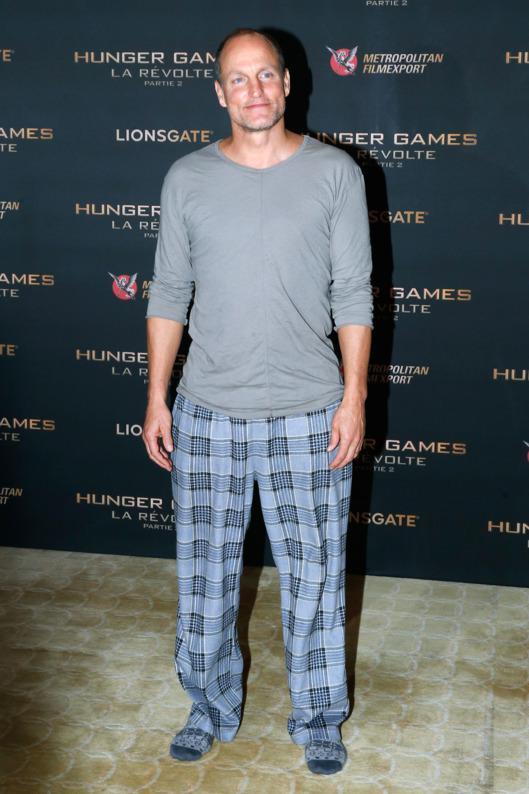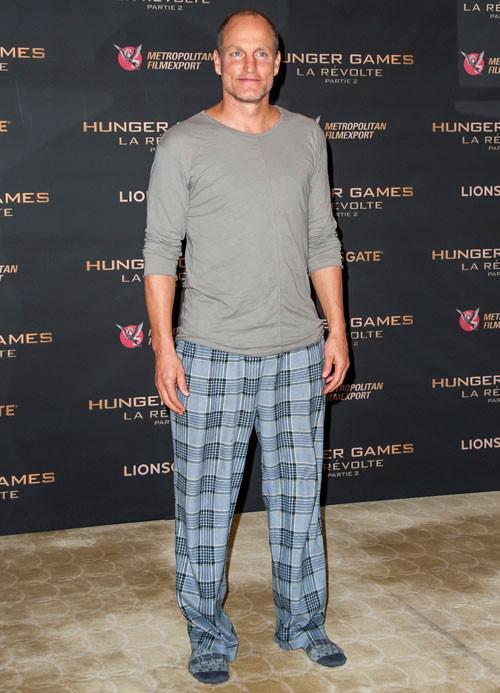The first image is the image on the left, the second image is the image on the right. Evaluate the accuracy of this statement regarding the images: "A man is wearing plaid pajama pants in the image on the right.". Is it true? Answer yes or no. Yes. The first image is the image on the left, the second image is the image on the right. For the images displayed, is the sentence "A man's silky diamond design pajama shirt has contrasting color at the collar, sleeve cuffs and pocket edge." factually correct? Answer yes or no. No. 